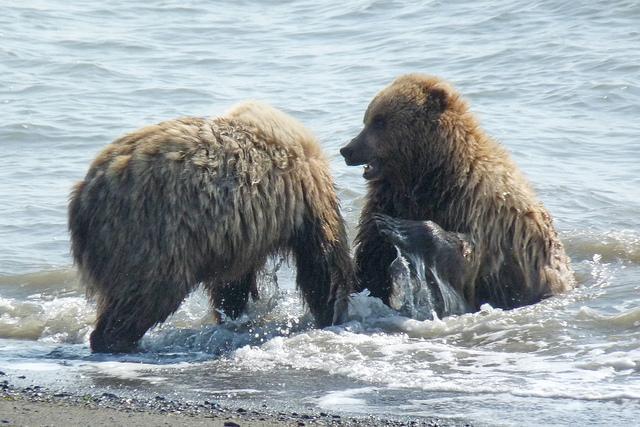How many bears are there?
Give a very brief answer. 2. How many bears can be seen?
Give a very brief answer. 2. How many people are riding bikes?
Give a very brief answer. 0. 